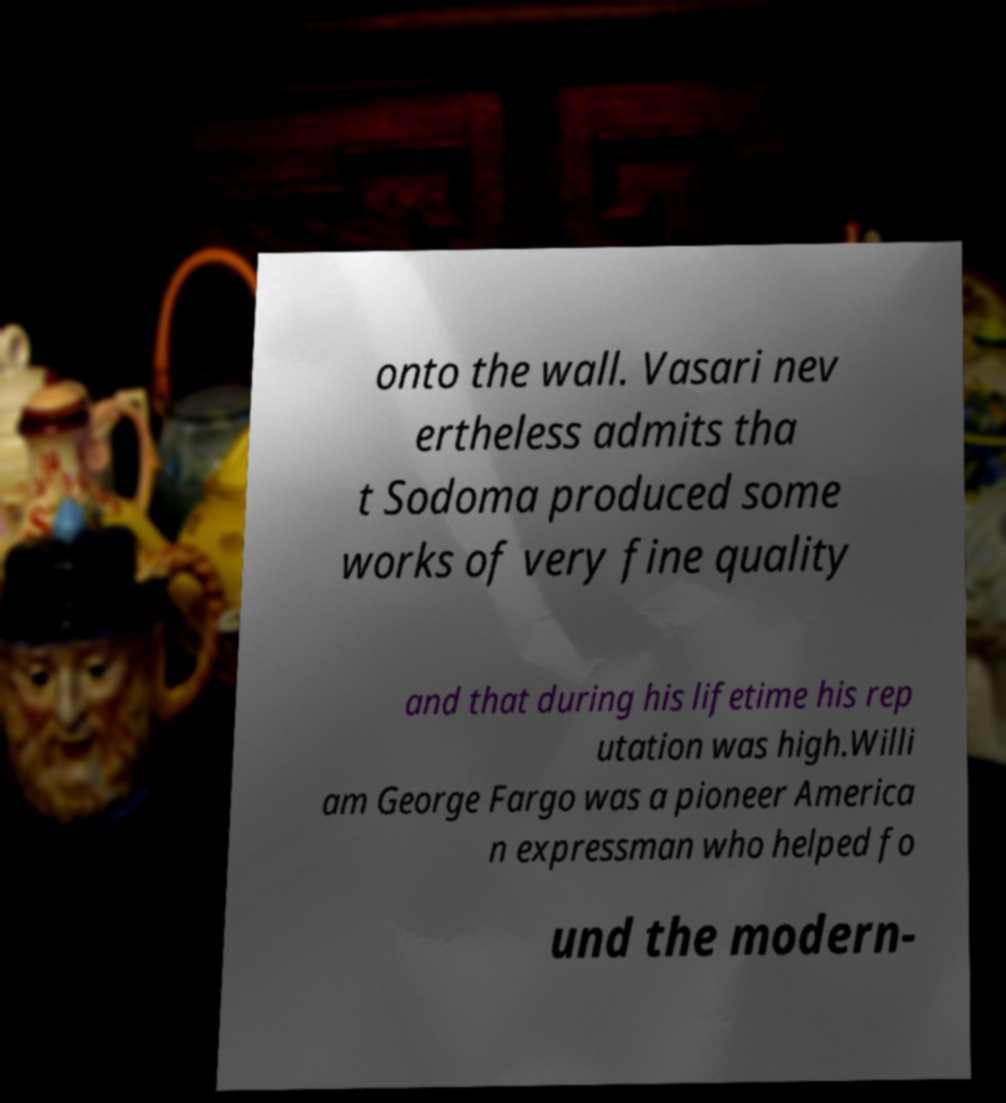Could you assist in decoding the text presented in this image and type it out clearly? onto the wall. Vasari nev ertheless admits tha t Sodoma produced some works of very fine quality and that during his lifetime his rep utation was high.Willi am George Fargo was a pioneer America n expressman who helped fo und the modern- 